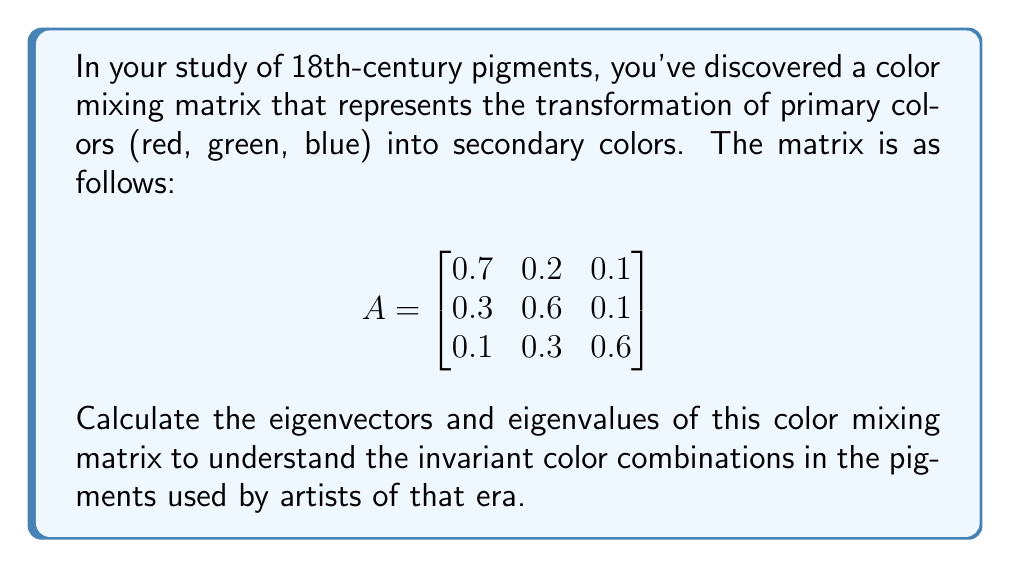Can you answer this question? To find the eigenvectors and eigenvalues of matrix A, we follow these steps:

1. Find the characteristic equation:
   $$det(A - \lambda I) = 0$$
   
   $$\begin{vmatrix}
   0.7 - \lambda & 0.2 & 0.1 \\
   0.3 & 0.6 - \lambda & 0.1 \\
   0.1 & 0.3 & 0.6 - \lambda
   \end{vmatrix} = 0$$

2. Expand the determinant:
   $$(0.7 - \lambda)[(0.6 - \lambda)(0.6 - \lambda) - 0.03] - 0.2[0.3(0.6 - \lambda) - 0.1] + 0.1[0.3(0.1) - 0.3(0.6 - \lambda)] = 0$$

3. Simplify:
   $$-\lambda^3 + 1.9\lambda^2 - 0.88\lambda + 0.116 = 0$$

4. Solve for λ (eigenvalues):
   Using a cubic equation solver, we get:
   $$\lambda_1 \approx 1, \lambda_2 \approx 0.5, \lambda_3 \approx 0.4$$

5. Find eigenvectors for each eigenvalue:
   For $\lambda_1 = 1$:
   $$(A - I)\vec{v_1} = \vec{0}$$
   Solving this system gives: $\vec{v_1} \approx (0.5774, 0.5774, 0.5774)^T$

   For $\lambda_2 = 0.5$:
   $$(A - 0.5I)\vec{v_2} = \vec{0}$$
   Solving this system gives: $\vec{v_2} \approx (-0.7071, 0.7071, 0)^T$

   For $\lambda_3 = 0.4$:
   $$(A - 0.4I)\vec{v_3} = \vec{0}$$
   Solving this system gives: $\vec{v_3} \approx (-0.4082, -0.4082, 0.8165)^T$

6. Normalize eigenvectors (optional, but often preferred):
   The eigenvectors given above are already normalized.
Answer: Eigenvalues: $\lambda_1 \approx 1, \lambda_2 \approx 0.5, \lambda_3 \approx 0.4$
Eigenvectors: $\vec{v_1} \approx (0.5774, 0.5774, 0.5774)^T, \vec{v_2} \approx (-0.7071, 0.7071, 0)^T, \vec{v_3} \approx (-0.4082, -0.4082, 0.8165)^T$ 